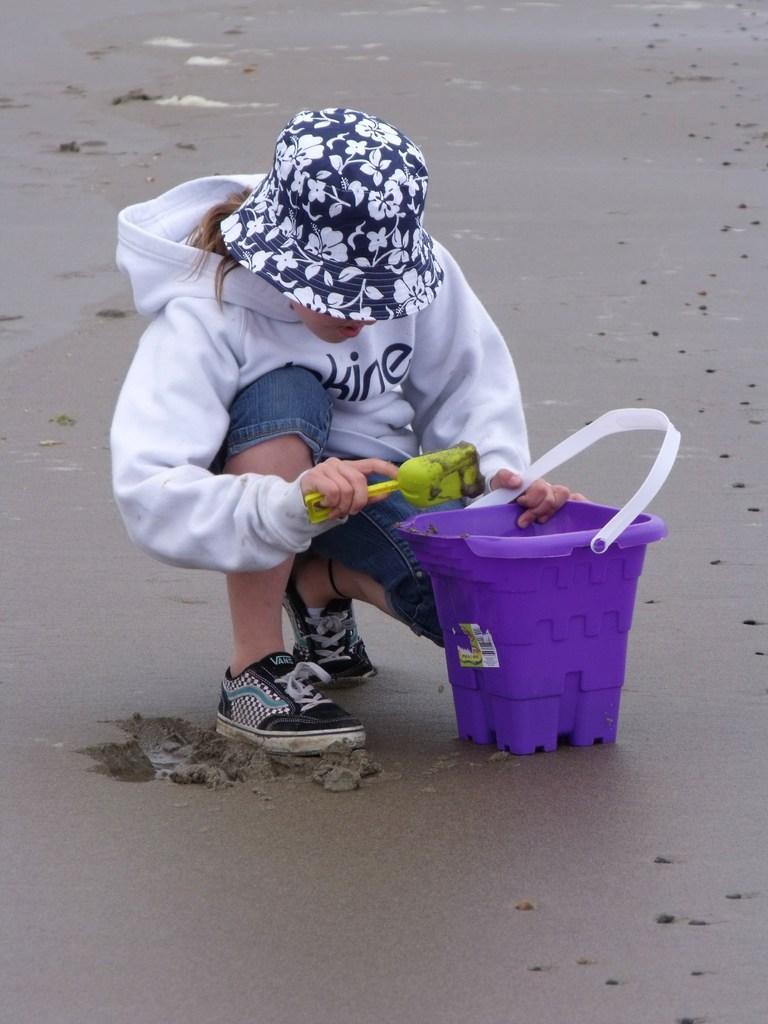Can you describe this image briefly? There is a girl sitting like squat position and holding a bucket and an object and wore hat and we can see bucket on the sand. 